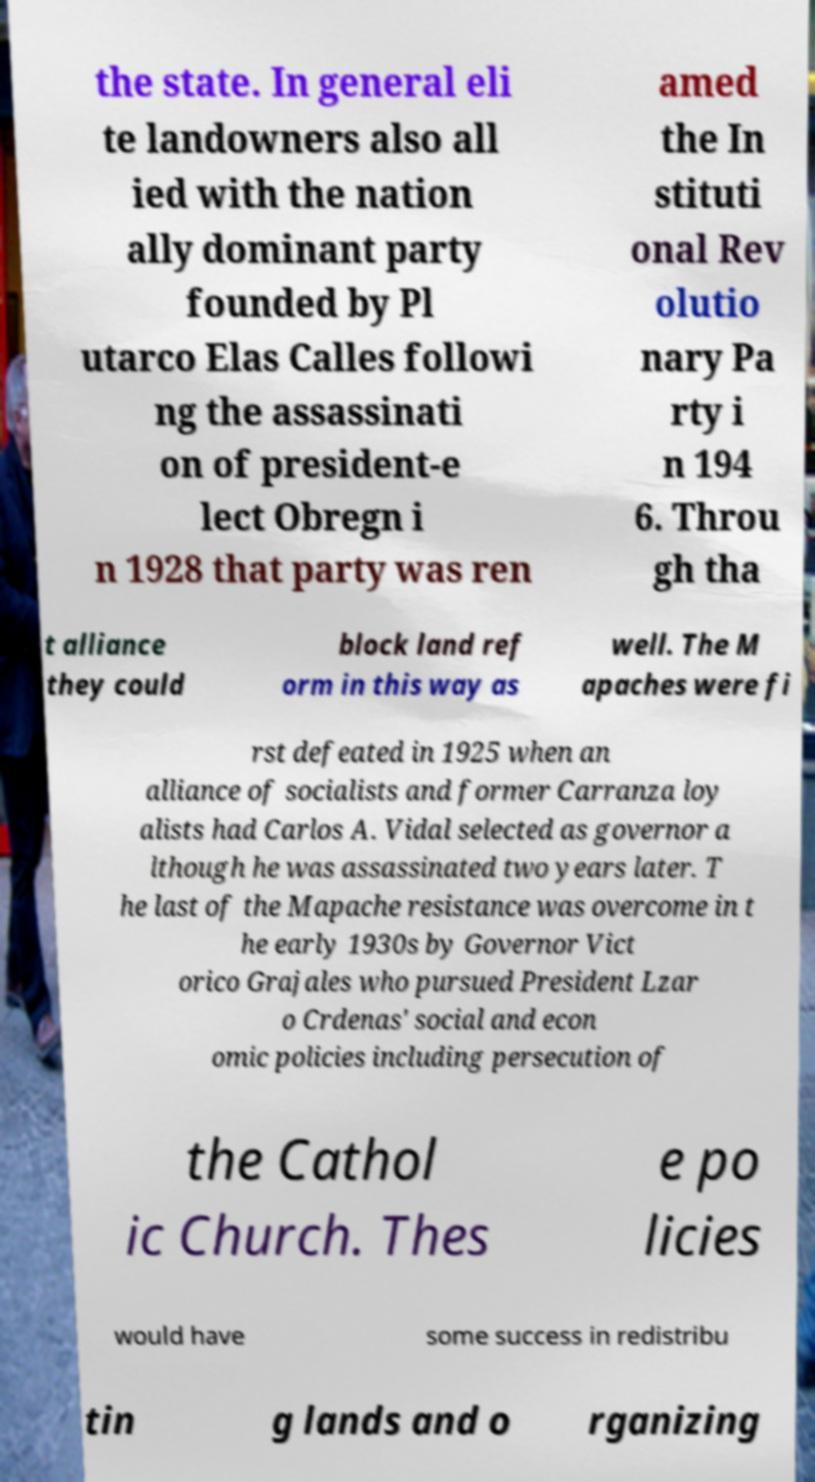Can you read and provide the text displayed in the image?This photo seems to have some interesting text. Can you extract and type it out for me? the state. In general eli te landowners also all ied with the nation ally dominant party founded by Pl utarco Elas Calles followi ng the assassinati on of president-e lect Obregn i n 1928 that party was ren amed the In stituti onal Rev olutio nary Pa rty i n 194 6. Throu gh tha t alliance they could block land ref orm in this way as well. The M apaches were fi rst defeated in 1925 when an alliance of socialists and former Carranza loy alists had Carlos A. Vidal selected as governor a lthough he was assassinated two years later. T he last of the Mapache resistance was overcome in t he early 1930s by Governor Vict orico Grajales who pursued President Lzar o Crdenas' social and econ omic policies including persecution of the Cathol ic Church. Thes e po licies would have some success in redistribu tin g lands and o rganizing 